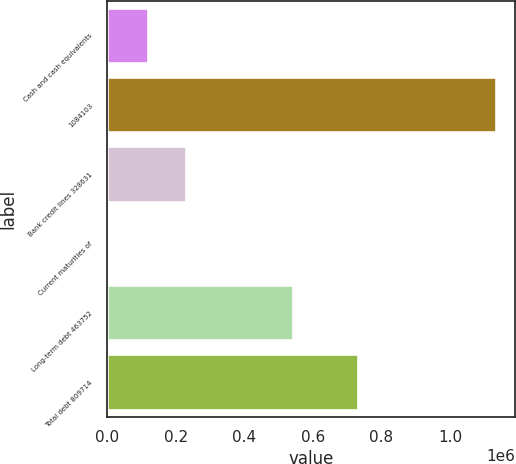Convert chart. <chart><loc_0><loc_0><loc_500><loc_500><bar_chart><fcel>Cash and cash equivalents<fcel>1084103<fcel>Bank credit lines 328631<fcel>Current maturities of<fcel>Long-term debt 463752<fcel>Total debt 809714<nl><fcel>118539<fcel>1.13306e+06<fcel>231263<fcel>5815<fcel>542776<fcel>731490<nl></chart> 